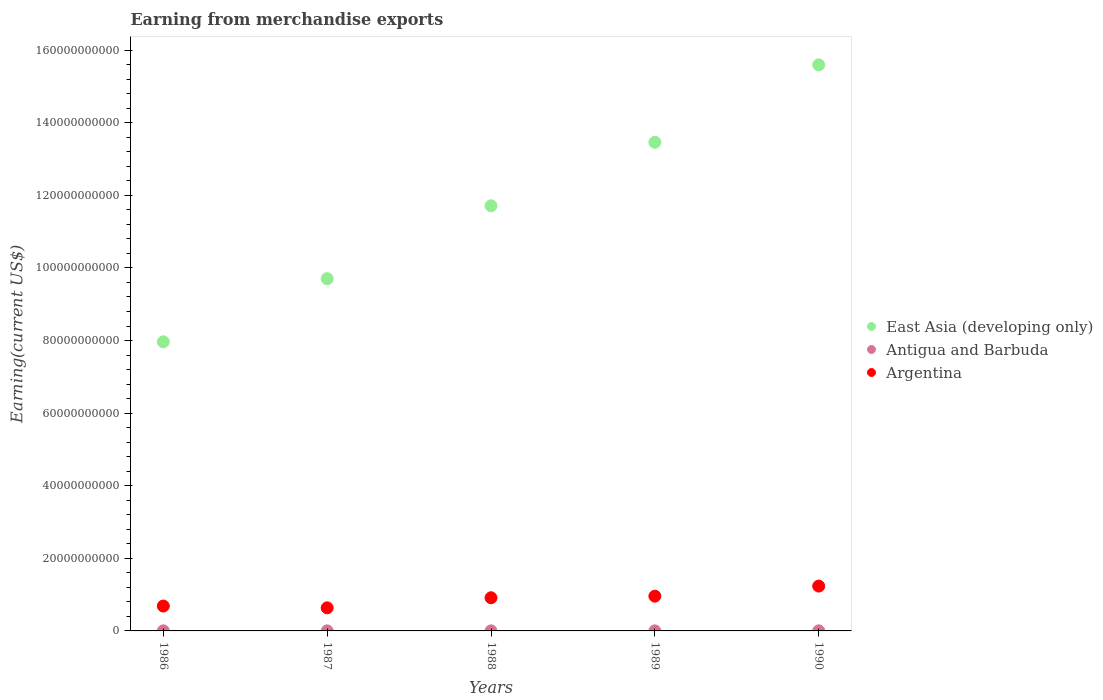How many different coloured dotlines are there?
Offer a terse response. 3. Is the number of dotlines equal to the number of legend labels?
Your answer should be compact. Yes. What is the amount earned from merchandise exports in East Asia (developing only) in 1988?
Offer a very short reply. 1.17e+11. Across all years, what is the maximum amount earned from merchandise exports in East Asia (developing only)?
Keep it short and to the point. 1.56e+11. Across all years, what is the minimum amount earned from merchandise exports in Antigua and Barbuda?
Keep it short and to the point. 1.60e+07. In which year was the amount earned from merchandise exports in Antigua and Barbuda maximum?
Provide a succinct answer. 1990. What is the total amount earned from merchandise exports in Antigua and Barbuda in the graph?
Your answer should be compact. 9.30e+07. What is the difference between the amount earned from merchandise exports in Argentina in 1988 and that in 1990?
Make the answer very short. -3.22e+09. What is the difference between the amount earned from merchandise exports in Argentina in 1988 and the amount earned from merchandise exports in Antigua and Barbuda in 1987?
Provide a short and direct response. 9.12e+09. What is the average amount earned from merchandise exports in Argentina per year?
Offer a terse response. 8.86e+09. In the year 1989, what is the difference between the amount earned from merchandise exports in Argentina and amount earned from merchandise exports in East Asia (developing only)?
Keep it short and to the point. -1.25e+11. What is the ratio of the amount earned from merchandise exports in Argentina in 1987 to that in 1990?
Ensure brevity in your answer.  0.51. What is the difference between the highest and the second highest amount earned from merchandise exports in Argentina?
Offer a terse response. 2.77e+09. Is the sum of the amount earned from merchandise exports in East Asia (developing only) in 1989 and 1990 greater than the maximum amount earned from merchandise exports in Antigua and Barbuda across all years?
Give a very brief answer. Yes. Is the amount earned from merchandise exports in Argentina strictly less than the amount earned from merchandise exports in East Asia (developing only) over the years?
Provide a short and direct response. Yes. How many years are there in the graph?
Provide a short and direct response. 5. Where does the legend appear in the graph?
Your response must be concise. Center right. How are the legend labels stacked?
Keep it short and to the point. Vertical. What is the title of the graph?
Your answer should be compact. Earning from merchandise exports. What is the label or title of the Y-axis?
Offer a very short reply. Earning(current US$). What is the Earning(current US$) of East Asia (developing only) in 1986?
Make the answer very short. 7.96e+1. What is the Earning(current US$) in Antigua and Barbuda in 1986?
Provide a succinct answer. 2.00e+07. What is the Earning(current US$) in Argentina in 1986?
Your response must be concise. 6.85e+09. What is the Earning(current US$) in East Asia (developing only) in 1987?
Give a very brief answer. 9.70e+1. What is the Earning(current US$) in Antigua and Barbuda in 1987?
Give a very brief answer. 1.90e+07. What is the Earning(current US$) in Argentina in 1987?
Make the answer very short. 6.36e+09. What is the Earning(current US$) in East Asia (developing only) in 1988?
Make the answer very short. 1.17e+11. What is the Earning(current US$) in Antigua and Barbuda in 1988?
Offer a very short reply. 1.70e+07. What is the Earning(current US$) in Argentina in 1988?
Your answer should be compact. 9.14e+09. What is the Earning(current US$) of East Asia (developing only) in 1989?
Your response must be concise. 1.35e+11. What is the Earning(current US$) in Antigua and Barbuda in 1989?
Provide a succinct answer. 1.60e+07. What is the Earning(current US$) in Argentina in 1989?
Make the answer very short. 9.58e+09. What is the Earning(current US$) in East Asia (developing only) in 1990?
Your answer should be compact. 1.56e+11. What is the Earning(current US$) in Antigua and Barbuda in 1990?
Offer a terse response. 2.10e+07. What is the Earning(current US$) in Argentina in 1990?
Ensure brevity in your answer.  1.24e+1. Across all years, what is the maximum Earning(current US$) of East Asia (developing only)?
Give a very brief answer. 1.56e+11. Across all years, what is the maximum Earning(current US$) in Antigua and Barbuda?
Offer a terse response. 2.10e+07. Across all years, what is the maximum Earning(current US$) of Argentina?
Ensure brevity in your answer.  1.24e+1. Across all years, what is the minimum Earning(current US$) in East Asia (developing only)?
Your response must be concise. 7.96e+1. Across all years, what is the minimum Earning(current US$) in Antigua and Barbuda?
Offer a very short reply. 1.60e+07. Across all years, what is the minimum Earning(current US$) in Argentina?
Offer a terse response. 6.36e+09. What is the total Earning(current US$) in East Asia (developing only) in the graph?
Your answer should be compact. 5.84e+11. What is the total Earning(current US$) of Antigua and Barbuda in the graph?
Offer a terse response. 9.30e+07. What is the total Earning(current US$) of Argentina in the graph?
Keep it short and to the point. 4.43e+1. What is the difference between the Earning(current US$) in East Asia (developing only) in 1986 and that in 1987?
Provide a succinct answer. -1.74e+1. What is the difference between the Earning(current US$) of Antigua and Barbuda in 1986 and that in 1987?
Your answer should be compact. 1.00e+06. What is the difference between the Earning(current US$) in Argentina in 1986 and that in 1987?
Offer a terse response. 4.92e+08. What is the difference between the Earning(current US$) of East Asia (developing only) in 1986 and that in 1988?
Give a very brief answer. -3.75e+1. What is the difference between the Earning(current US$) in Antigua and Barbuda in 1986 and that in 1988?
Ensure brevity in your answer.  3.00e+06. What is the difference between the Earning(current US$) in Argentina in 1986 and that in 1988?
Offer a terse response. -2.28e+09. What is the difference between the Earning(current US$) of East Asia (developing only) in 1986 and that in 1989?
Make the answer very short. -5.50e+1. What is the difference between the Earning(current US$) in Argentina in 1986 and that in 1989?
Your answer should be very brief. -2.73e+09. What is the difference between the Earning(current US$) of East Asia (developing only) in 1986 and that in 1990?
Ensure brevity in your answer.  -7.63e+1. What is the difference between the Earning(current US$) of Antigua and Barbuda in 1986 and that in 1990?
Ensure brevity in your answer.  -1.00e+06. What is the difference between the Earning(current US$) in Argentina in 1986 and that in 1990?
Offer a very short reply. -5.50e+09. What is the difference between the Earning(current US$) of East Asia (developing only) in 1987 and that in 1988?
Offer a very short reply. -2.01e+1. What is the difference between the Earning(current US$) in Antigua and Barbuda in 1987 and that in 1988?
Ensure brevity in your answer.  2.00e+06. What is the difference between the Earning(current US$) in Argentina in 1987 and that in 1988?
Provide a succinct answer. -2.78e+09. What is the difference between the Earning(current US$) in East Asia (developing only) in 1987 and that in 1989?
Your answer should be very brief. -3.76e+1. What is the difference between the Earning(current US$) of Antigua and Barbuda in 1987 and that in 1989?
Your response must be concise. 3.00e+06. What is the difference between the Earning(current US$) of Argentina in 1987 and that in 1989?
Keep it short and to the point. -3.22e+09. What is the difference between the Earning(current US$) in East Asia (developing only) in 1987 and that in 1990?
Provide a succinct answer. -5.89e+1. What is the difference between the Earning(current US$) of Argentina in 1987 and that in 1990?
Keep it short and to the point. -5.99e+09. What is the difference between the Earning(current US$) in East Asia (developing only) in 1988 and that in 1989?
Your response must be concise. -1.75e+1. What is the difference between the Earning(current US$) of Antigua and Barbuda in 1988 and that in 1989?
Your answer should be compact. 1.00e+06. What is the difference between the Earning(current US$) in Argentina in 1988 and that in 1989?
Offer a terse response. -4.44e+08. What is the difference between the Earning(current US$) of East Asia (developing only) in 1988 and that in 1990?
Offer a terse response. -3.88e+1. What is the difference between the Earning(current US$) in Argentina in 1988 and that in 1990?
Offer a very short reply. -3.22e+09. What is the difference between the Earning(current US$) in East Asia (developing only) in 1989 and that in 1990?
Offer a very short reply. -2.13e+1. What is the difference between the Earning(current US$) of Antigua and Barbuda in 1989 and that in 1990?
Your answer should be compact. -5.00e+06. What is the difference between the Earning(current US$) of Argentina in 1989 and that in 1990?
Your response must be concise. -2.77e+09. What is the difference between the Earning(current US$) of East Asia (developing only) in 1986 and the Earning(current US$) of Antigua and Barbuda in 1987?
Provide a short and direct response. 7.96e+1. What is the difference between the Earning(current US$) of East Asia (developing only) in 1986 and the Earning(current US$) of Argentina in 1987?
Provide a short and direct response. 7.33e+1. What is the difference between the Earning(current US$) in Antigua and Barbuda in 1986 and the Earning(current US$) in Argentina in 1987?
Offer a terse response. -6.34e+09. What is the difference between the Earning(current US$) of East Asia (developing only) in 1986 and the Earning(current US$) of Antigua and Barbuda in 1988?
Make the answer very short. 7.96e+1. What is the difference between the Earning(current US$) of East Asia (developing only) in 1986 and the Earning(current US$) of Argentina in 1988?
Your answer should be compact. 7.05e+1. What is the difference between the Earning(current US$) in Antigua and Barbuda in 1986 and the Earning(current US$) in Argentina in 1988?
Your answer should be compact. -9.12e+09. What is the difference between the Earning(current US$) of East Asia (developing only) in 1986 and the Earning(current US$) of Antigua and Barbuda in 1989?
Provide a short and direct response. 7.96e+1. What is the difference between the Earning(current US$) in East Asia (developing only) in 1986 and the Earning(current US$) in Argentina in 1989?
Your answer should be very brief. 7.01e+1. What is the difference between the Earning(current US$) of Antigua and Barbuda in 1986 and the Earning(current US$) of Argentina in 1989?
Your response must be concise. -9.56e+09. What is the difference between the Earning(current US$) in East Asia (developing only) in 1986 and the Earning(current US$) in Antigua and Barbuda in 1990?
Provide a short and direct response. 7.96e+1. What is the difference between the Earning(current US$) in East Asia (developing only) in 1986 and the Earning(current US$) in Argentina in 1990?
Provide a short and direct response. 6.73e+1. What is the difference between the Earning(current US$) of Antigua and Barbuda in 1986 and the Earning(current US$) of Argentina in 1990?
Offer a terse response. -1.23e+1. What is the difference between the Earning(current US$) in East Asia (developing only) in 1987 and the Earning(current US$) in Antigua and Barbuda in 1988?
Ensure brevity in your answer.  9.70e+1. What is the difference between the Earning(current US$) in East Asia (developing only) in 1987 and the Earning(current US$) in Argentina in 1988?
Your answer should be compact. 8.79e+1. What is the difference between the Earning(current US$) of Antigua and Barbuda in 1987 and the Earning(current US$) of Argentina in 1988?
Provide a succinct answer. -9.12e+09. What is the difference between the Earning(current US$) in East Asia (developing only) in 1987 and the Earning(current US$) in Antigua and Barbuda in 1989?
Offer a terse response. 9.70e+1. What is the difference between the Earning(current US$) of East Asia (developing only) in 1987 and the Earning(current US$) of Argentina in 1989?
Give a very brief answer. 8.75e+1. What is the difference between the Earning(current US$) of Antigua and Barbuda in 1987 and the Earning(current US$) of Argentina in 1989?
Provide a succinct answer. -9.56e+09. What is the difference between the Earning(current US$) of East Asia (developing only) in 1987 and the Earning(current US$) of Antigua and Barbuda in 1990?
Your answer should be compact. 9.70e+1. What is the difference between the Earning(current US$) in East Asia (developing only) in 1987 and the Earning(current US$) in Argentina in 1990?
Provide a short and direct response. 8.47e+1. What is the difference between the Earning(current US$) in Antigua and Barbuda in 1987 and the Earning(current US$) in Argentina in 1990?
Make the answer very short. -1.23e+1. What is the difference between the Earning(current US$) in East Asia (developing only) in 1988 and the Earning(current US$) in Antigua and Barbuda in 1989?
Your response must be concise. 1.17e+11. What is the difference between the Earning(current US$) of East Asia (developing only) in 1988 and the Earning(current US$) of Argentina in 1989?
Provide a succinct answer. 1.08e+11. What is the difference between the Earning(current US$) in Antigua and Barbuda in 1988 and the Earning(current US$) in Argentina in 1989?
Provide a succinct answer. -9.56e+09. What is the difference between the Earning(current US$) of East Asia (developing only) in 1988 and the Earning(current US$) of Antigua and Barbuda in 1990?
Give a very brief answer. 1.17e+11. What is the difference between the Earning(current US$) of East Asia (developing only) in 1988 and the Earning(current US$) of Argentina in 1990?
Offer a terse response. 1.05e+11. What is the difference between the Earning(current US$) of Antigua and Barbuda in 1988 and the Earning(current US$) of Argentina in 1990?
Make the answer very short. -1.23e+1. What is the difference between the Earning(current US$) in East Asia (developing only) in 1989 and the Earning(current US$) in Antigua and Barbuda in 1990?
Make the answer very short. 1.35e+11. What is the difference between the Earning(current US$) in East Asia (developing only) in 1989 and the Earning(current US$) in Argentina in 1990?
Ensure brevity in your answer.  1.22e+11. What is the difference between the Earning(current US$) of Antigua and Barbuda in 1989 and the Earning(current US$) of Argentina in 1990?
Give a very brief answer. -1.23e+1. What is the average Earning(current US$) of East Asia (developing only) per year?
Your answer should be very brief. 1.17e+11. What is the average Earning(current US$) in Antigua and Barbuda per year?
Make the answer very short. 1.86e+07. What is the average Earning(current US$) in Argentina per year?
Provide a short and direct response. 8.86e+09. In the year 1986, what is the difference between the Earning(current US$) in East Asia (developing only) and Earning(current US$) in Antigua and Barbuda?
Offer a very short reply. 7.96e+1. In the year 1986, what is the difference between the Earning(current US$) of East Asia (developing only) and Earning(current US$) of Argentina?
Keep it short and to the point. 7.28e+1. In the year 1986, what is the difference between the Earning(current US$) of Antigua and Barbuda and Earning(current US$) of Argentina?
Your response must be concise. -6.83e+09. In the year 1987, what is the difference between the Earning(current US$) in East Asia (developing only) and Earning(current US$) in Antigua and Barbuda?
Keep it short and to the point. 9.70e+1. In the year 1987, what is the difference between the Earning(current US$) of East Asia (developing only) and Earning(current US$) of Argentina?
Offer a very short reply. 9.07e+1. In the year 1987, what is the difference between the Earning(current US$) in Antigua and Barbuda and Earning(current US$) in Argentina?
Offer a terse response. -6.34e+09. In the year 1988, what is the difference between the Earning(current US$) in East Asia (developing only) and Earning(current US$) in Antigua and Barbuda?
Provide a short and direct response. 1.17e+11. In the year 1988, what is the difference between the Earning(current US$) of East Asia (developing only) and Earning(current US$) of Argentina?
Provide a short and direct response. 1.08e+11. In the year 1988, what is the difference between the Earning(current US$) of Antigua and Barbuda and Earning(current US$) of Argentina?
Offer a very short reply. -9.12e+09. In the year 1989, what is the difference between the Earning(current US$) in East Asia (developing only) and Earning(current US$) in Antigua and Barbuda?
Give a very brief answer. 1.35e+11. In the year 1989, what is the difference between the Earning(current US$) in East Asia (developing only) and Earning(current US$) in Argentina?
Your answer should be compact. 1.25e+11. In the year 1989, what is the difference between the Earning(current US$) in Antigua and Barbuda and Earning(current US$) in Argentina?
Your answer should be very brief. -9.56e+09. In the year 1990, what is the difference between the Earning(current US$) in East Asia (developing only) and Earning(current US$) in Antigua and Barbuda?
Provide a short and direct response. 1.56e+11. In the year 1990, what is the difference between the Earning(current US$) of East Asia (developing only) and Earning(current US$) of Argentina?
Give a very brief answer. 1.44e+11. In the year 1990, what is the difference between the Earning(current US$) in Antigua and Barbuda and Earning(current US$) in Argentina?
Ensure brevity in your answer.  -1.23e+1. What is the ratio of the Earning(current US$) in East Asia (developing only) in 1986 to that in 1987?
Give a very brief answer. 0.82. What is the ratio of the Earning(current US$) in Antigua and Barbuda in 1986 to that in 1987?
Your answer should be compact. 1.05. What is the ratio of the Earning(current US$) in Argentina in 1986 to that in 1987?
Your response must be concise. 1.08. What is the ratio of the Earning(current US$) in East Asia (developing only) in 1986 to that in 1988?
Provide a succinct answer. 0.68. What is the ratio of the Earning(current US$) of Antigua and Barbuda in 1986 to that in 1988?
Your answer should be very brief. 1.18. What is the ratio of the Earning(current US$) of Argentina in 1986 to that in 1988?
Your answer should be compact. 0.75. What is the ratio of the Earning(current US$) of East Asia (developing only) in 1986 to that in 1989?
Your answer should be compact. 0.59. What is the ratio of the Earning(current US$) of Antigua and Barbuda in 1986 to that in 1989?
Provide a succinct answer. 1.25. What is the ratio of the Earning(current US$) of Argentina in 1986 to that in 1989?
Make the answer very short. 0.72. What is the ratio of the Earning(current US$) in East Asia (developing only) in 1986 to that in 1990?
Provide a succinct answer. 0.51. What is the ratio of the Earning(current US$) of Argentina in 1986 to that in 1990?
Provide a short and direct response. 0.55. What is the ratio of the Earning(current US$) of East Asia (developing only) in 1987 to that in 1988?
Your response must be concise. 0.83. What is the ratio of the Earning(current US$) in Antigua and Barbuda in 1987 to that in 1988?
Offer a very short reply. 1.12. What is the ratio of the Earning(current US$) in Argentina in 1987 to that in 1988?
Give a very brief answer. 0.7. What is the ratio of the Earning(current US$) in East Asia (developing only) in 1987 to that in 1989?
Keep it short and to the point. 0.72. What is the ratio of the Earning(current US$) in Antigua and Barbuda in 1987 to that in 1989?
Provide a succinct answer. 1.19. What is the ratio of the Earning(current US$) of Argentina in 1987 to that in 1989?
Ensure brevity in your answer.  0.66. What is the ratio of the Earning(current US$) in East Asia (developing only) in 1987 to that in 1990?
Your answer should be very brief. 0.62. What is the ratio of the Earning(current US$) of Antigua and Barbuda in 1987 to that in 1990?
Ensure brevity in your answer.  0.9. What is the ratio of the Earning(current US$) in Argentina in 1987 to that in 1990?
Keep it short and to the point. 0.51. What is the ratio of the Earning(current US$) of East Asia (developing only) in 1988 to that in 1989?
Make the answer very short. 0.87. What is the ratio of the Earning(current US$) of Antigua and Barbuda in 1988 to that in 1989?
Your response must be concise. 1.06. What is the ratio of the Earning(current US$) of Argentina in 1988 to that in 1989?
Make the answer very short. 0.95. What is the ratio of the Earning(current US$) of East Asia (developing only) in 1988 to that in 1990?
Make the answer very short. 0.75. What is the ratio of the Earning(current US$) in Antigua and Barbuda in 1988 to that in 1990?
Offer a terse response. 0.81. What is the ratio of the Earning(current US$) of Argentina in 1988 to that in 1990?
Offer a terse response. 0.74. What is the ratio of the Earning(current US$) of East Asia (developing only) in 1989 to that in 1990?
Give a very brief answer. 0.86. What is the ratio of the Earning(current US$) in Antigua and Barbuda in 1989 to that in 1990?
Ensure brevity in your answer.  0.76. What is the ratio of the Earning(current US$) of Argentina in 1989 to that in 1990?
Provide a succinct answer. 0.78. What is the difference between the highest and the second highest Earning(current US$) in East Asia (developing only)?
Make the answer very short. 2.13e+1. What is the difference between the highest and the second highest Earning(current US$) in Antigua and Barbuda?
Keep it short and to the point. 1.00e+06. What is the difference between the highest and the second highest Earning(current US$) of Argentina?
Your answer should be very brief. 2.77e+09. What is the difference between the highest and the lowest Earning(current US$) in East Asia (developing only)?
Ensure brevity in your answer.  7.63e+1. What is the difference between the highest and the lowest Earning(current US$) in Antigua and Barbuda?
Offer a terse response. 5.00e+06. What is the difference between the highest and the lowest Earning(current US$) in Argentina?
Offer a very short reply. 5.99e+09. 